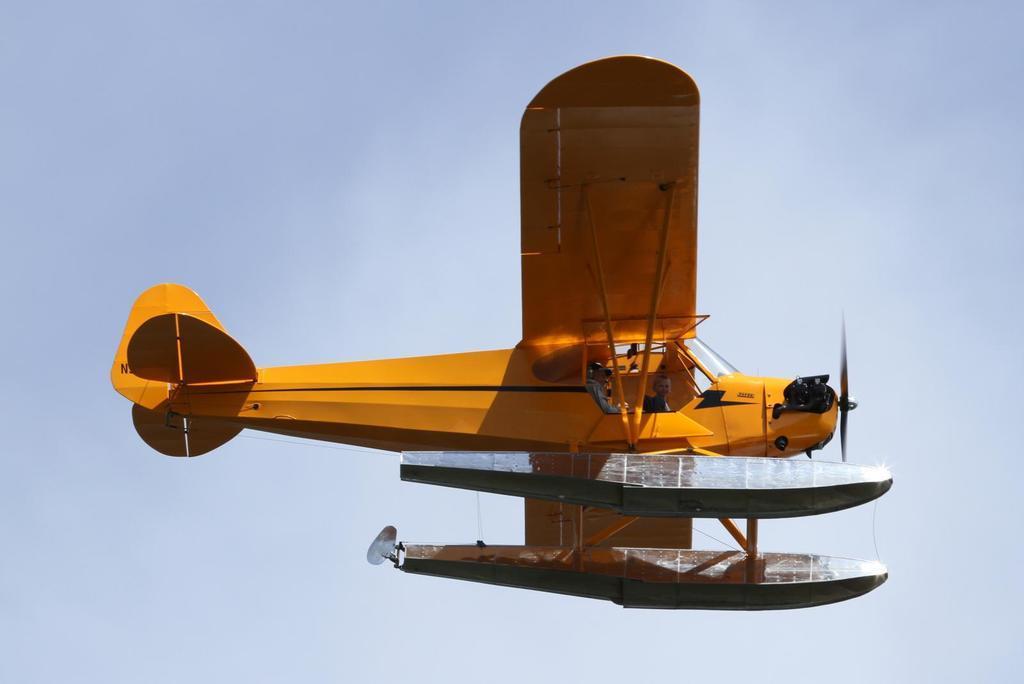In one or two sentences, can you explain what this image depicts? Here we can see an airplane. In the background there is sky. 